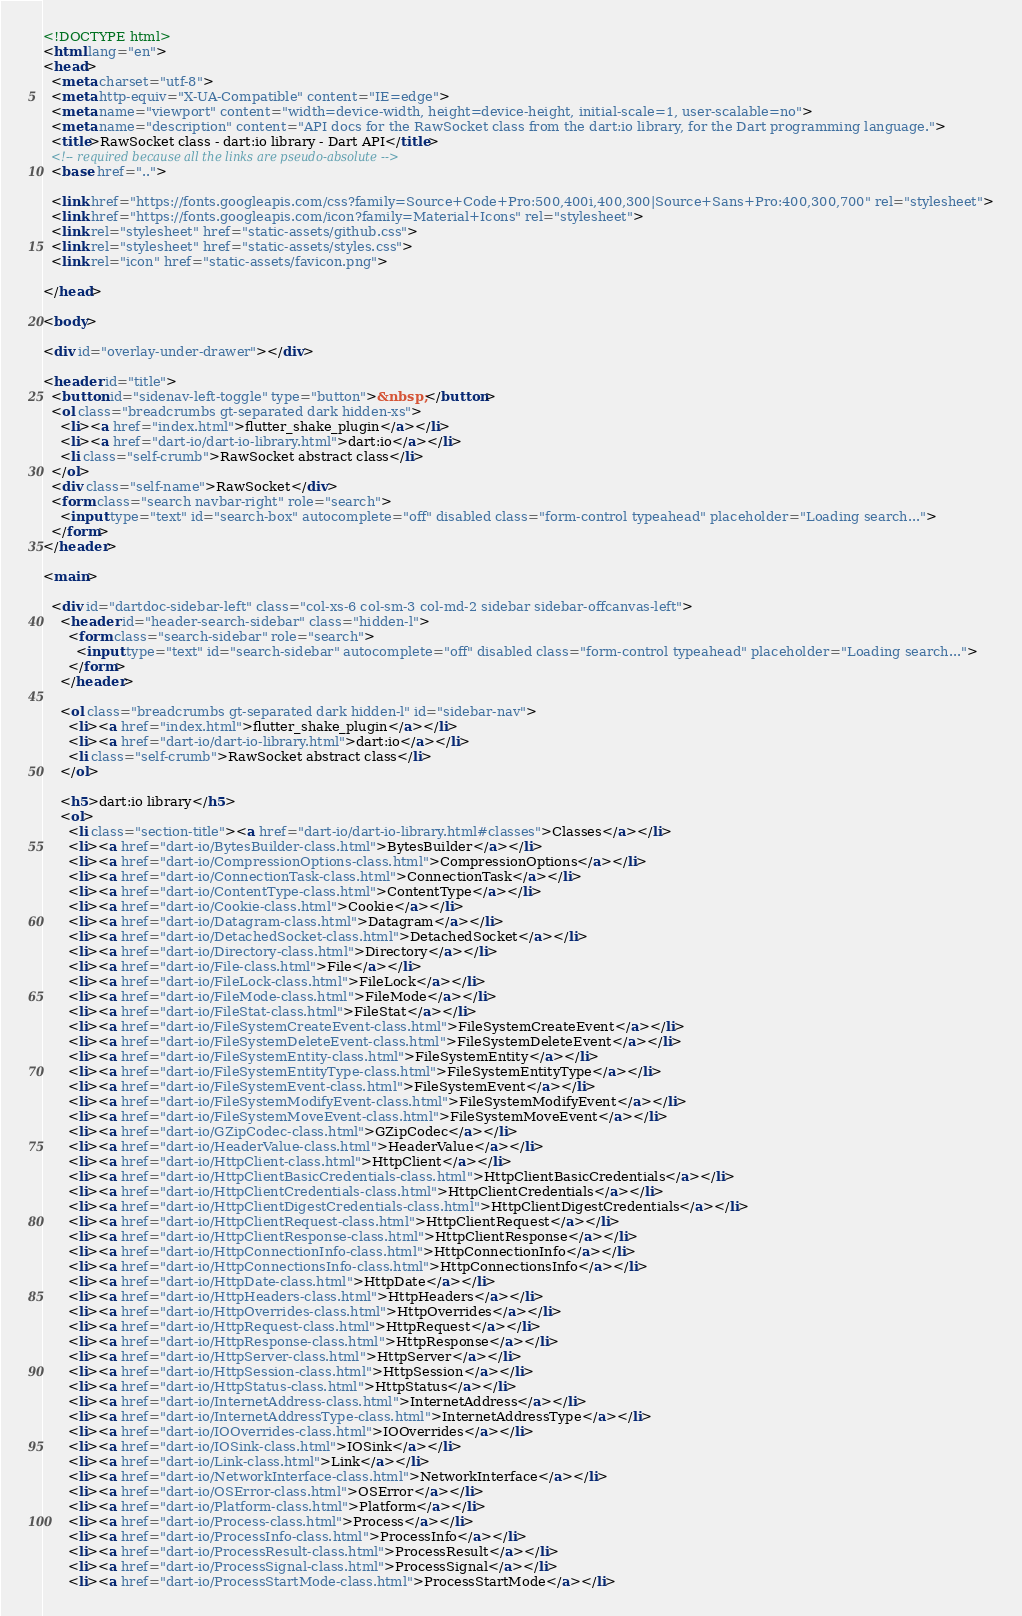Convert code to text. <code><loc_0><loc_0><loc_500><loc_500><_HTML_><!DOCTYPE html>
<html lang="en">
<head>
  <meta charset="utf-8">
  <meta http-equiv="X-UA-Compatible" content="IE=edge">
  <meta name="viewport" content="width=device-width, height=device-height, initial-scale=1, user-scalable=no">
  <meta name="description" content="API docs for the RawSocket class from the dart:io library, for the Dart programming language.">
  <title>RawSocket class - dart:io library - Dart API</title>
  <!-- required because all the links are pseudo-absolute -->
  <base href="..">

  <link href="https://fonts.googleapis.com/css?family=Source+Code+Pro:500,400i,400,300|Source+Sans+Pro:400,300,700" rel="stylesheet">
  <link href="https://fonts.googleapis.com/icon?family=Material+Icons" rel="stylesheet">
  <link rel="stylesheet" href="static-assets/github.css">
  <link rel="stylesheet" href="static-assets/styles.css">
  <link rel="icon" href="static-assets/favicon.png">
  
</head>

<body>

<div id="overlay-under-drawer"></div>

<header id="title">
  <button id="sidenav-left-toggle" type="button">&nbsp;</button>
  <ol class="breadcrumbs gt-separated dark hidden-xs">
    <li><a href="index.html">flutter_shake_plugin</a></li>
    <li><a href="dart-io/dart-io-library.html">dart:io</a></li>
    <li class="self-crumb">RawSocket abstract class</li>
  </ol>
  <div class="self-name">RawSocket</div>
  <form class="search navbar-right" role="search">
    <input type="text" id="search-box" autocomplete="off" disabled class="form-control typeahead" placeholder="Loading search...">
  </form>
</header>

<main>

  <div id="dartdoc-sidebar-left" class="col-xs-6 col-sm-3 col-md-2 sidebar sidebar-offcanvas-left">
    <header id="header-search-sidebar" class="hidden-l">
      <form class="search-sidebar" role="search">
        <input type="text" id="search-sidebar" autocomplete="off" disabled class="form-control typeahead" placeholder="Loading search...">
      </form>
    </header>
    
    <ol class="breadcrumbs gt-separated dark hidden-l" id="sidebar-nav">
      <li><a href="index.html">flutter_shake_plugin</a></li>
      <li><a href="dart-io/dart-io-library.html">dart:io</a></li>
      <li class="self-crumb">RawSocket abstract class</li>
    </ol>
    
    <h5>dart:io library</h5>
    <ol>
      <li class="section-title"><a href="dart-io/dart-io-library.html#classes">Classes</a></li>
      <li><a href="dart-io/BytesBuilder-class.html">BytesBuilder</a></li>
      <li><a href="dart-io/CompressionOptions-class.html">CompressionOptions</a></li>
      <li><a href="dart-io/ConnectionTask-class.html">ConnectionTask</a></li>
      <li><a href="dart-io/ContentType-class.html">ContentType</a></li>
      <li><a href="dart-io/Cookie-class.html">Cookie</a></li>
      <li><a href="dart-io/Datagram-class.html">Datagram</a></li>
      <li><a href="dart-io/DetachedSocket-class.html">DetachedSocket</a></li>
      <li><a href="dart-io/Directory-class.html">Directory</a></li>
      <li><a href="dart-io/File-class.html">File</a></li>
      <li><a href="dart-io/FileLock-class.html">FileLock</a></li>
      <li><a href="dart-io/FileMode-class.html">FileMode</a></li>
      <li><a href="dart-io/FileStat-class.html">FileStat</a></li>
      <li><a href="dart-io/FileSystemCreateEvent-class.html">FileSystemCreateEvent</a></li>
      <li><a href="dart-io/FileSystemDeleteEvent-class.html">FileSystemDeleteEvent</a></li>
      <li><a href="dart-io/FileSystemEntity-class.html">FileSystemEntity</a></li>
      <li><a href="dart-io/FileSystemEntityType-class.html">FileSystemEntityType</a></li>
      <li><a href="dart-io/FileSystemEvent-class.html">FileSystemEvent</a></li>
      <li><a href="dart-io/FileSystemModifyEvent-class.html">FileSystemModifyEvent</a></li>
      <li><a href="dart-io/FileSystemMoveEvent-class.html">FileSystemMoveEvent</a></li>
      <li><a href="dart-io/GZipCodec-class.html">GZipCodec</a></li>
      <li><a href="dart-io/HeaderValue-class.html">HeaderValue</a></li>
      <li><a href="dart-io/HttpClient-class.html">HttpClient</a></li>
      <li><a href="dart-io/HttpClientBasicCredentials-class.html">HttpClientBasicCredentials</a></li>
      <li><a href="dart-io/HttpClientCredentials-class.html">HttpClientCredentials</a></li>
      <li><a href="dart-io/HttpClientDigestCredentials-class.html">HttpClientDigestCredentials</a></li>
      <li><a href="dart-io/HttpClientRequest-class.html">HttpClientRequest</a></li>
      <li><a href="dart-io/HttpClientResponse-class.html">HttpClientResponse</a></li>
      <li><a href="dart-io/HttpConnectionInfo-class.html">HttpConnectionInfo</a></li>
      <li><a href="dart-io/HttpConnectionsInfo-class.html">HttpConnectionsInfo</a></li>
      <li><a href="dart-io/HttpDate-class.html">HttpDate</a></li>
      <li><a href="dart-io/HttpHeaders-class.html">HttpHeaders</a></li>
      <li><a href="dart-io/HttpOverrides-class.html">HttpOverrides</a></li>
      <li><a href="dart-io/HttpRequest-class.html">HttpRequest</a></li>
      <li><a href="dart-io/HttpResponse-class.html">HttpResponse</a></li>
      <li><a href="dart-io/HttpServer-class.html">HttpServer</a></li>
      <li><a href="dart-io/HttpSession-class.html">HttpSession</a></li>
      <li><a href="dart-io/HttpStatus-class.html">HttpStatus</a></li>
      <li><a href="dart-io/InternetAddress-class.html">InternetAddress</a></li>
      <li><a href="dart-io/InternetAddressType-class.html">InternetAddressType</a></li>
      <li><a href="dart-io/IOOverrides-class.html">IOOverrides</a></li>
      <li><a href="dart-io/IOSink-class.html">IOSink</a></li>
      <li><a href="dart-io/Link-class.html">Link</a></li>
      <li><a href="dart-io/NetworkInterface-class.html">NetworkInterface</a></li>
      <li><a href="dart-io/OSError-class.html">OSError</a></li>
      <li><a href="dart-io/Platform-class.html">Platform</a></li>
      <li><a href="dart-io/Process-class.html">Process</a></li>
      <li><a href="dart-io/ProcessInfo-class.html">ProcessInfo</a></li>
      <li><a href="dart-io/ProcessResult-class.html">ProcessResult</a></li>
      <li><a href="dart-io/ProcessSignal-class.html">ProcessSignal</a></li>
      <li><a href="dart-io/ProcessStartMode-class.html">ProcessStartMode</a></li></code> 